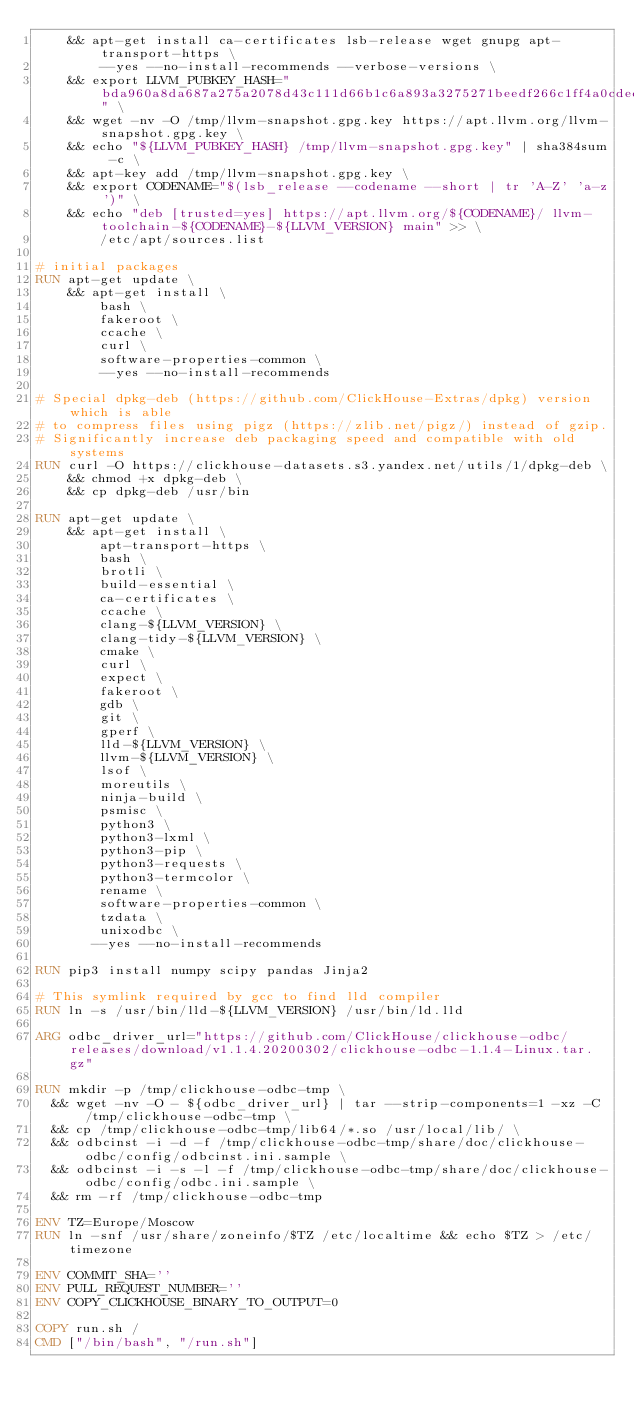Convert code to text. <code><loc_0><loc_0><loc_500><loc_500><_Dockerfile_>    && apt-get install ca-certificates lsb-release wget gnupg apt-transport-https \
        --yes --no-install-recommends --verbose-versions \
    && export LLVM_PUBKEY_HASH="bda960a8da687a275a2078d43c111d66b1c6a893a3275271beedf266c1ff4a0cdecb429c7a5cccf9f486ea7aa43fd27f" \
    && wget -nv -O /tmp/llvm-snapshot.gpg.key https://apt.llvm.org/llvm-snapshot.gpg.key \
    && echo "${LLVM_PUBKEY_HASH} /tmp/llvm-snapshot.gpg.key" | sha384sum -c \
    && apt-key add /tmp/llvm-snapshot.gpg.key \
    && export CODENAME="$(lsb_release --codename --short | tr 'A-Z' 'a-z')" \
    && echo "deb [trusted=yes] https://apt.llvm.org/${CODENAME}/ llvm-toolchain-${CODENAME}-${LLVM_VERSION} main" >> \
        /etc/apt/sources.list

# initial packages
RUN apt-get update \
    && apt-get install \
        bash \
        fakeroot \
        ccache \
        curl \
        software-properties-common \
        --yes --no-install-recommends

# Special dpkg-deb (https://github.com/ClickHouse-Extras/dpkg) version which is able
# to compress files using pigz (https://zlib.net/pigz/) instead of gzip.
# Significantly increase deb packaging speed and compatible with old systems
RUN curl -O https://clickhouse-datasets.s3.yandex.net/utils/1/dpkg-deb \
    && chmod +x dpkg-deb \
    && cp dpkg-deb /usr/bin

RUN apt-get update \
    && apt-get install \
        apt-transport-https \
        bash \
        brotli \
        build-essential \
        ca-certificates \
        ccache \
        clang-${LLVM_VERSION} \
        clang-tidy-${LLVM_VERSION} \
        cmake \
        curl \
        expect \
        fakeroot \
        gdb \
        git \
        gperf \
        lld-${LLVM_VERSION} \
        llvm-${LLVM_VERSION} \
        lsof \
        moreutils \
        ninja-build \
        psmisc \
        python3 \
        python3-lxml \
        python3-pip \
        python3-requests \
        python3-termcolor \
        rename \
        software-properties-common \
        tzdata \
        unixodbc \
       --yes --no-install-recommends

RUN pip3 install numpy scipy pandas Jinja2

# This symlink required by gcc to find lld compiler
RUN ln -s /usr/bin/lld-${LLVM_VERSION} /usr/bin/ld.lld

ARG odbc_driver_url="https://github.com/ClickHouse/clickhouse-odbc/releases/download/v1.1.4.20200302/clickhouse-odbc-1.1.4-Linux.tar.gz"

RUN mkdir -p /tmp/clickhouse-odbc-tmp \
  && wget -nv -O - ${odbc_driver_url} | tar --strip-components=1 -xz -C /tmp/clickhouse-odbc-tmp \
  && cp /tmp/clickhouse-odbc-tmp/lib64/*.so /usr/local/lib/ \
  && odbcinst -i -d -f /tmp/clickhouse-odbc-tmp/share/doc/clickhouse-odbc/config/odbcinst.ini.sample \
  && odbcinst -i -s -l -f /tmp/clickhouse-odbc-tmp/share/doc/clickhouse-odbc/config/odbc.ini.sample \
  && rm -rf /tmp/clickhouse-odbc-tmp

ENV TZ=Europe/Moscow
RUN ln -snf /usr/share/zoneinfo/$TZ /etc/localtime && echo $TZ > /etc/timezone

ENV COMMIT_SHA=''
ENV PULL_REQUEST_NUMBER=''
ENV COPY_CLICKHOUSE_BINARY_TO_OUTPUT=0

COPY run.sh /
CMD ["/bin/bash", "/run.sh"]
</code> 